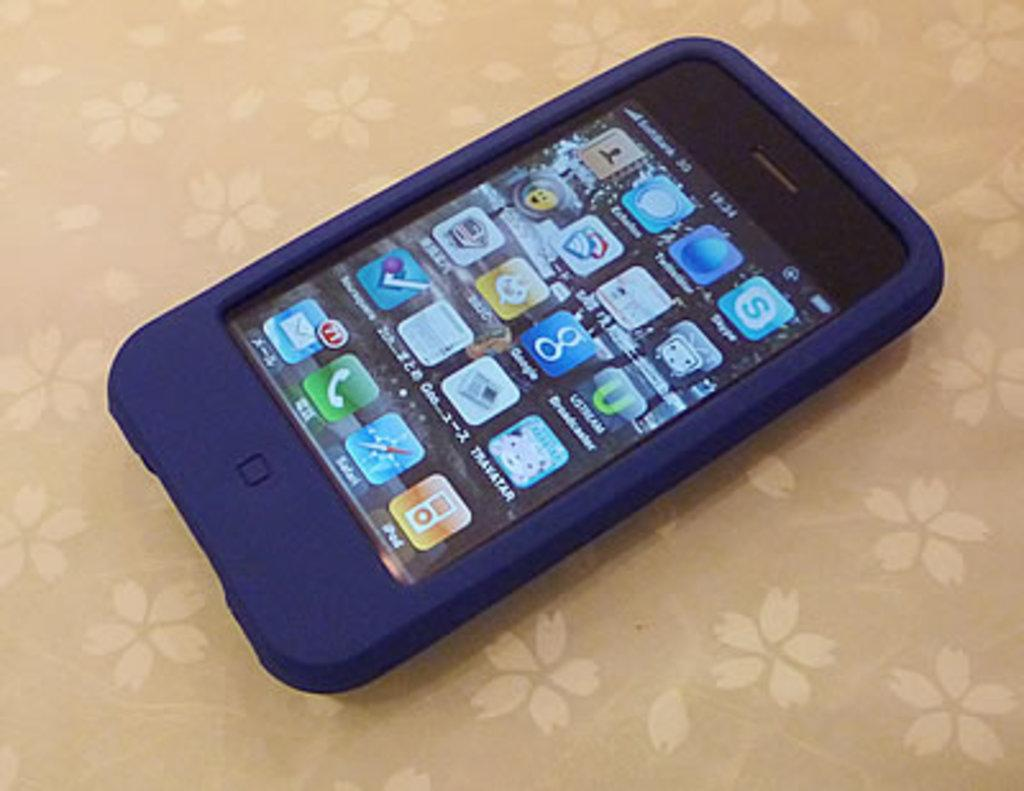<image>
Write a terse but informative summary of the picture. a cell phone in a blue rubber case with a SKYPE icon on the front 